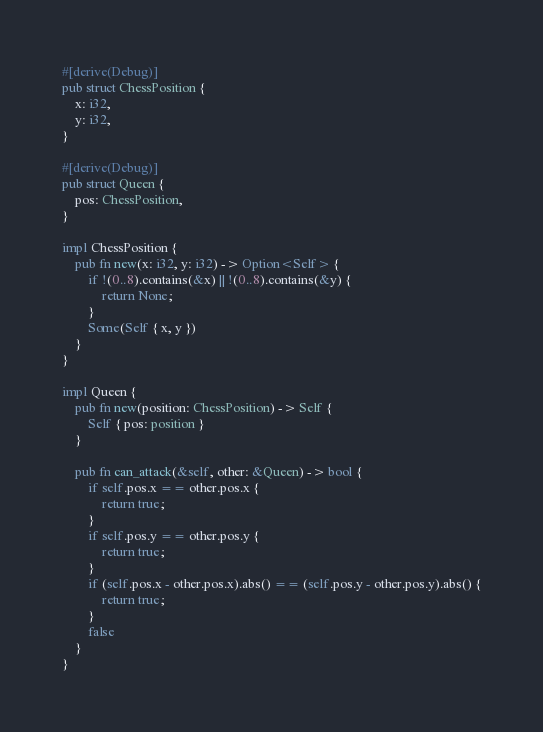Convert code to text. <code><loc_0><loc_0><loc_500><loc_500><_Rust_>#[derive(Debug)]
pub struct ChessPosition {
    x: i32,
    y: i32,
}

#[derive(Debug)]
pub struct Queen {
    pos: ChessPosition,
}

impl ChessPosition {
    pub fn new(x: i32, y: i32) -> Option<Self> {
        if !(0..8).contains(&x) || !(0..8).contains(&y) {
            return None;
        }
        Some(Self { x, y })
    }
}

impl Queen {
    pub fn new(position: ChessPosition) -> Self {
        Self { pos: position }
    }

    pub fn can_attack(&self, other: &Queen) -> bool {
        if self.pos.x == other.pos.x {
            return true;
        }
        if self.pos.y == other.pos.y {
            return true;
        }
        if (self.pos.x - other.pos.x).abs() == (self.pos.y - other.pos.y).abs() {
            return true;
        }
        false
    }
}
</code> 